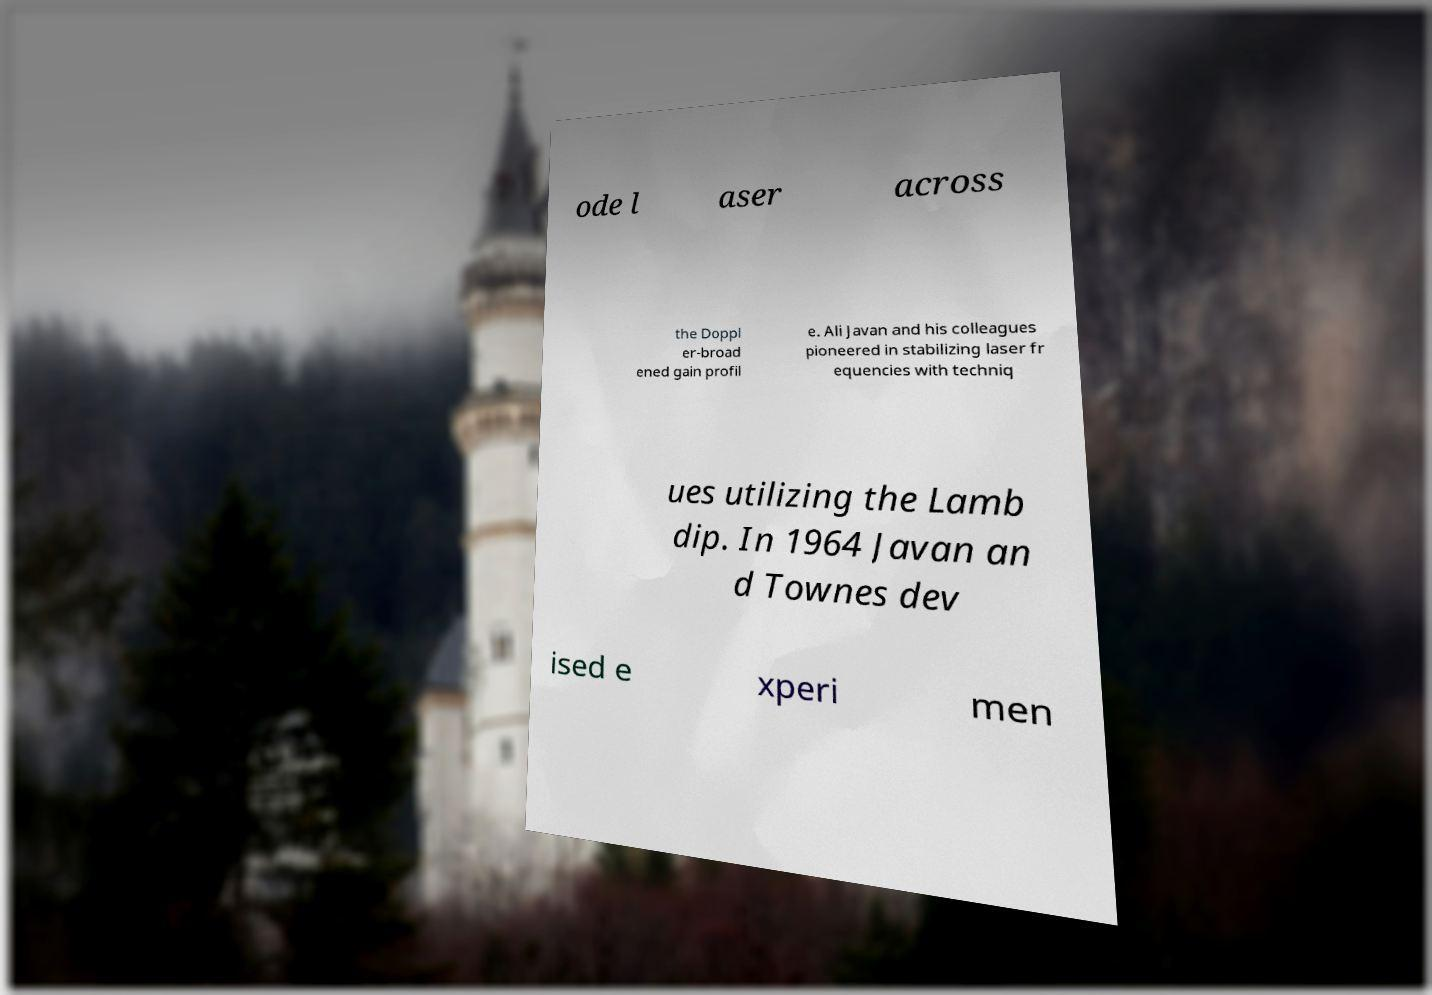Please identify and transcribe the text found in this image. ode l aser across the Doppl er-broad ened gain profil e. Ali Javan and his colleagues pioneered in stabilizing laser fr equencies with techniq ues utilizing the Lamb dip. In 1964 Javan an d Townes dev ised e xperi men 